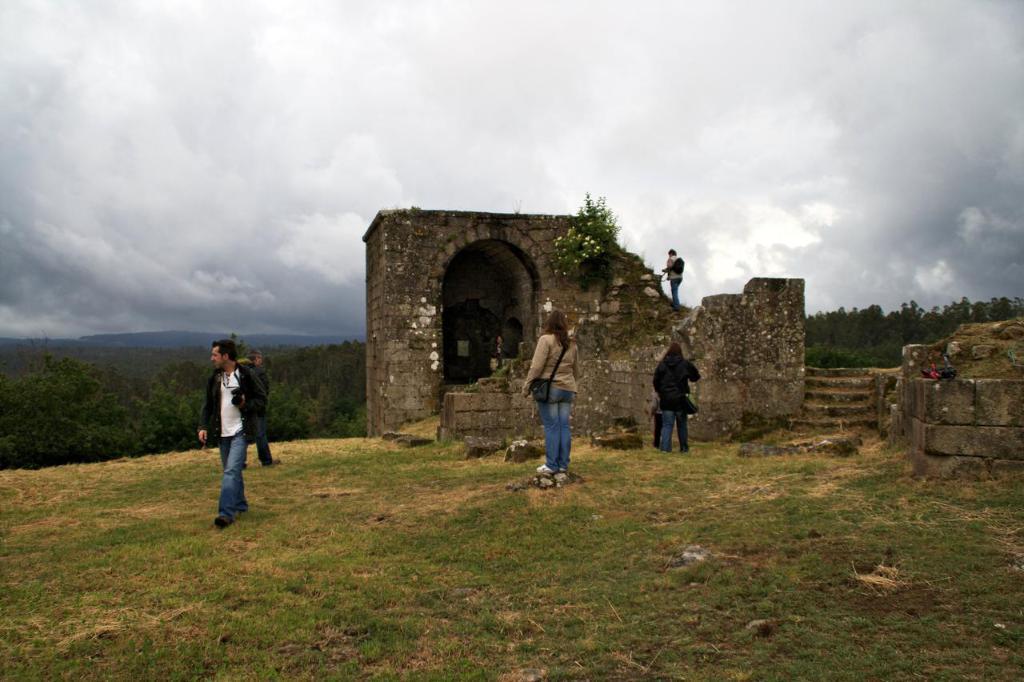Describe this image in one or two sentences. Here in this picture we can see a group of people standing and walking on the ground, which is fully covered with grass and in the middle we can see old monumental structure and walls present and we can also see plants and trees present in the far and we can see mountains present and we can see the sky is fully covered with clouds and we can see the people are carrying bags with them. 